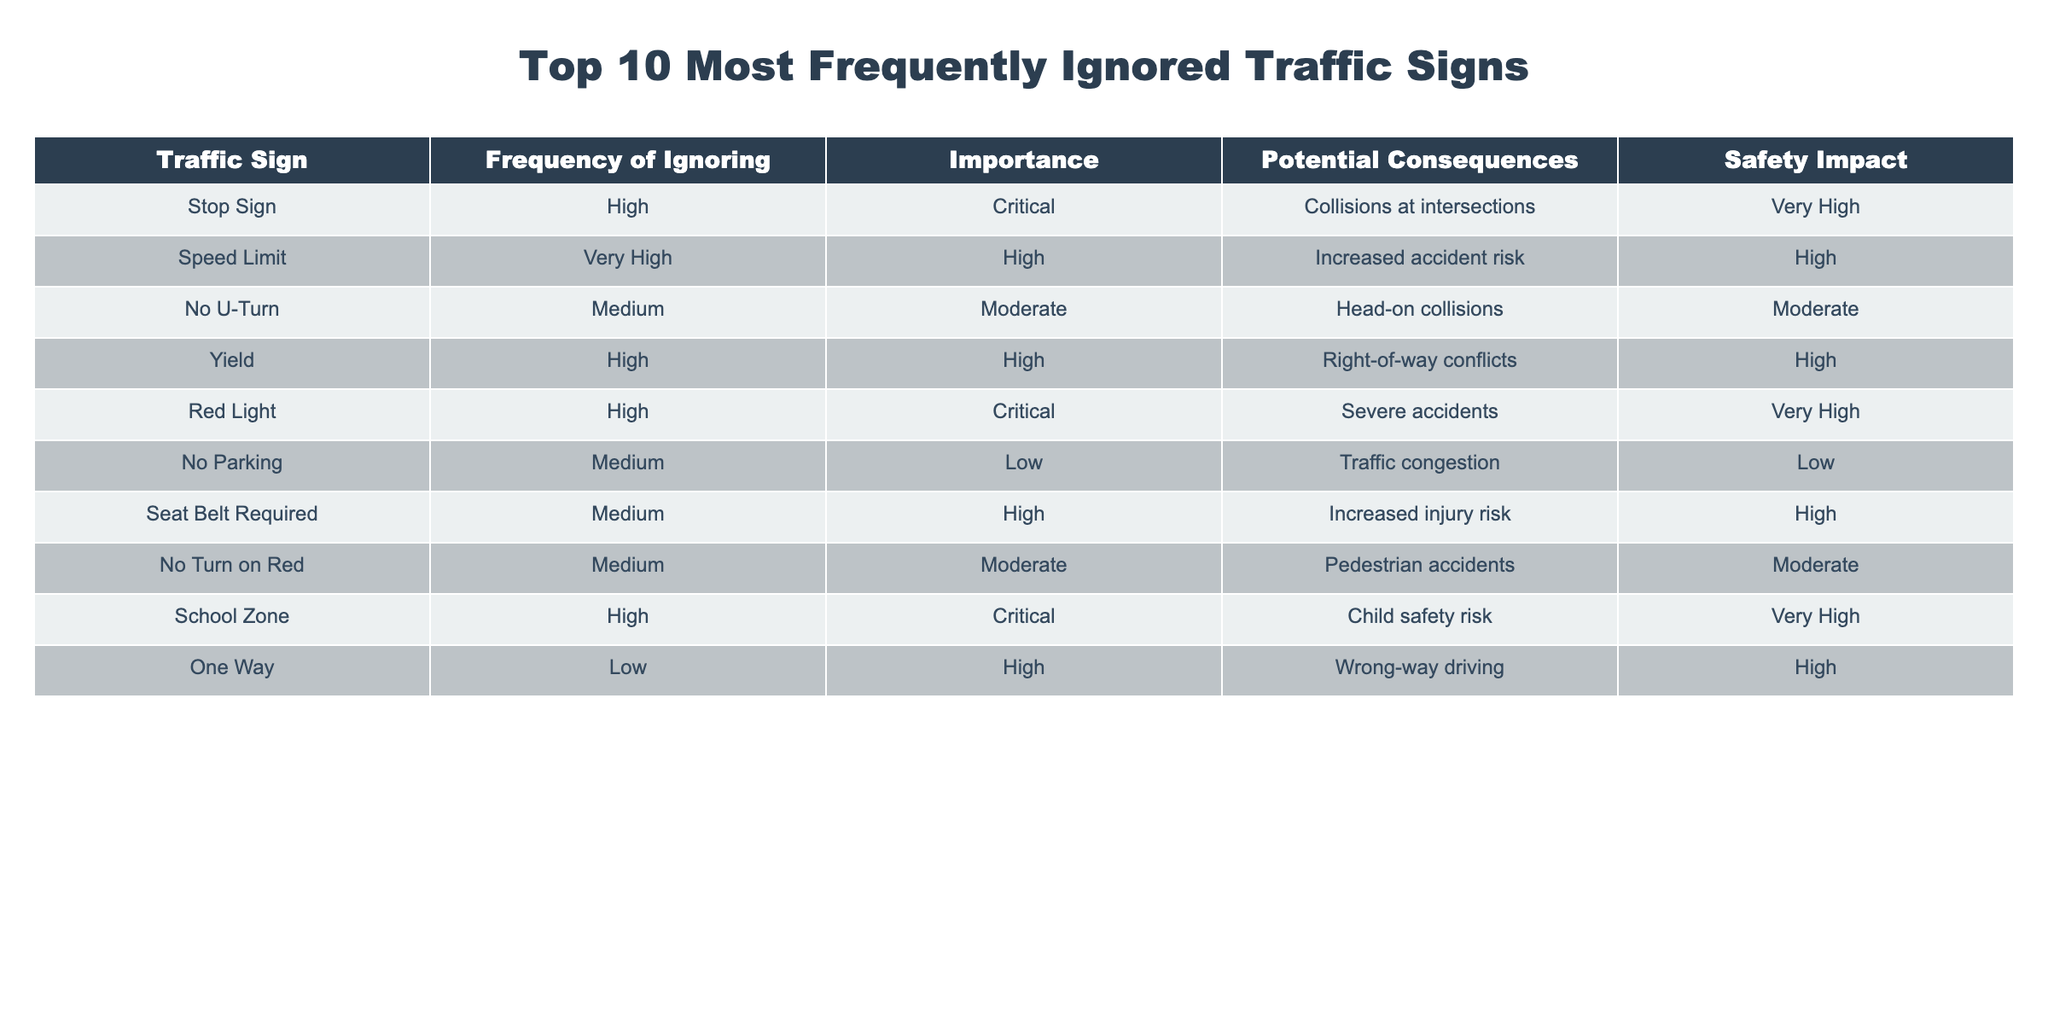What is the traffic sign with the highest frequency of ignoring? The table indicates that both the Stop Sign and Red Light have a "High" frequency for ignoring. However, in terms of critical importance, Red Light is more severe. Hence, it can be inferred that the most frequently ignored sign, which is also critical, is likely the Red Light.
Answer: Red Light What is the importance level of the No Parking sign? According to the table, the No Parking sign is listed as having a "Low" importance level.
Answer: Low How many signs have a "Critical" importance level? By counting the rows in the table, we observe three signs: Stop Sign, Red Light, and School Zone have a "Critical" importance level.
Answer: 3 Which traffic sign has the lowest frequency of ignoring? The table shows that the One Way sign has a "Low" frequency of ignoring.
Answer: One Way Is it true that ignoring the Speed Limit sign has a high safety impact? The table states that the Speed Limit sign has a "High" importance level and an associated safety impact as "High." Thus, if ignored, it poses a significant risk.
Answer: Yes What is the potential consequence of ignoring the School Zone sign? The School Zone sign has a potential consequence mentioned as "Child safety risk," indicating that ignoring it could endanger children.
Answer: Child safety risk How does the safety impact of ignoring the Seat Belt Required sign compare to that of the No U-Turn sign? The Seat Belt Required sign has a "High" safety impact while the No U-Turn sign has a "Moderate" safety impact. Thus, ignoring the Seat Belt Required sign poses a higher safety risk.
Answer: Seat Belt Required has a higher safety impact If we disregard the Medium frequency signs, how many signs have either a High or Very High frequency of ignoring? Excluding the Medium frequency signs (No U-Turn, No Parking, and Seat Belt Required), we are left with seven signs. Four signs have a High frequency (Speed Limit, Yield, Stop Sign, Red Light, and School Zone), and three have Very High (none listed here, so just the four.) Total signs are four.
Answer: 4 Which sign has the most severe potential consequences? The Red Light sign is associated with "Severe accidents," which is the most severe potential consequence listed in the table.
Answer: Red Light Are there any signs listed that have both a "Medium" frequency and "Low" importance? Yes, the No Parking sign has a "Medium" frequency of ignoring and a "Low" importance.
Answer: Yes What is the only sign that has a "Low" frequency of ignoring and "High" importance? The table shows that the One Way sign is the only one listed with a "Low" frequency of ignoring and a "High" importance level.
Answer: One Way 